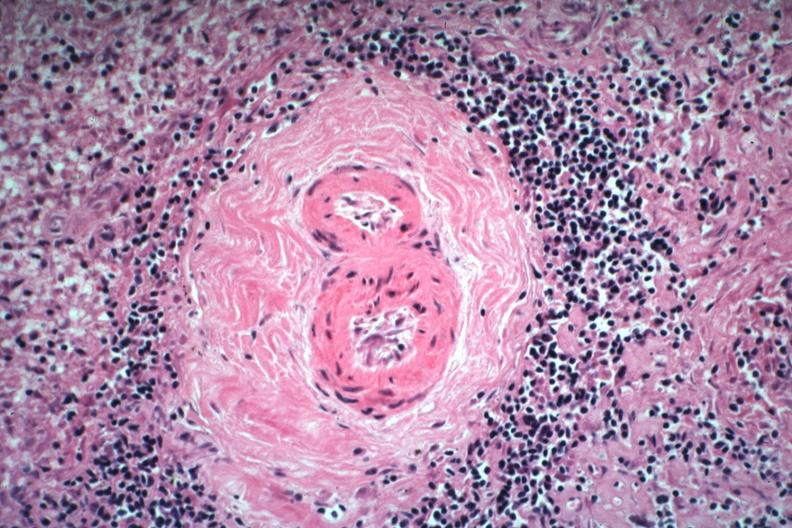what is present?
Answer the question using a single word or phrase. Spleen 